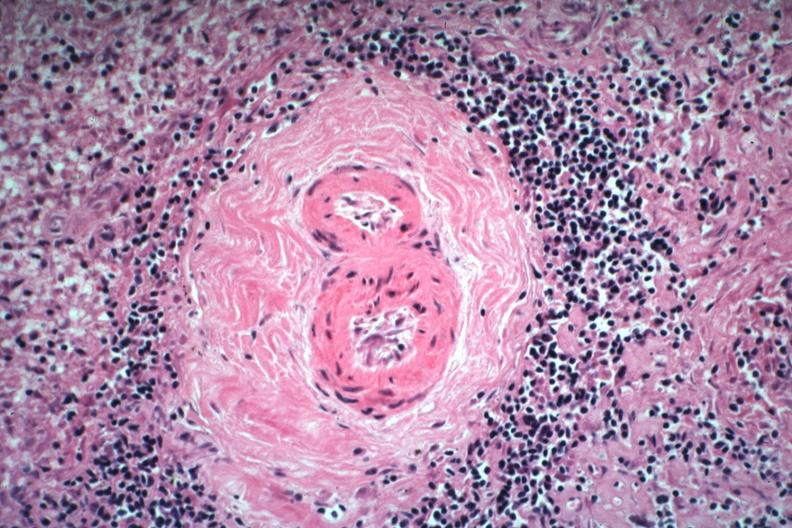what is present?
Answer the question using a single word or phrase. Spleen 